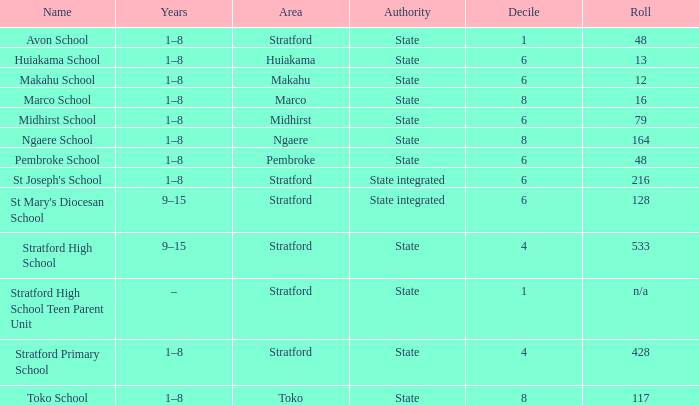What is the lowest decile with a state authority and Midhirst school? 6.0. 